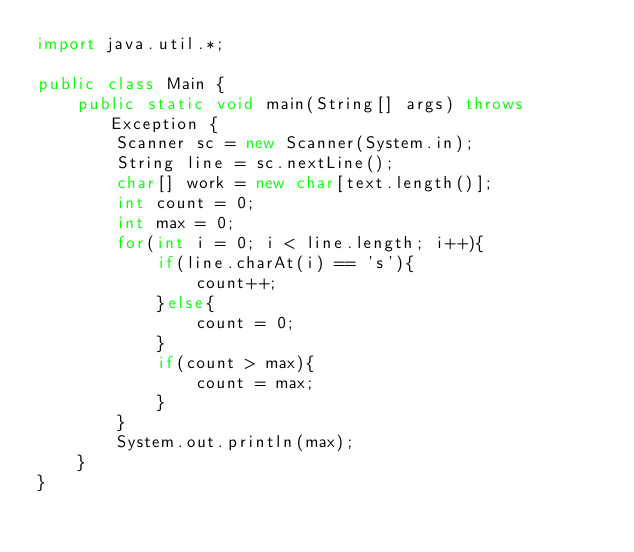<code> <loc_0><loc_0><loc_500><loc_500><_Java_>import java.util.*;

public class Main {
    public static void main(String[] args) throws Exception {
        Scanner sc = new Scanner(System.in);
        String line = sc.nextLine();
      	char[] work = new char[text.length()];
      	int count = 0;
      	int max = 0;
        for(int i = 0; i < line.length; i++){
			if(line.charAt(i) == 's'){
            	count++;
            }else{
				count = 0;
            }
       		if(count > max){
				count = max;
            }
    	}
      	System.out.println(max);
    }
}
</code> 